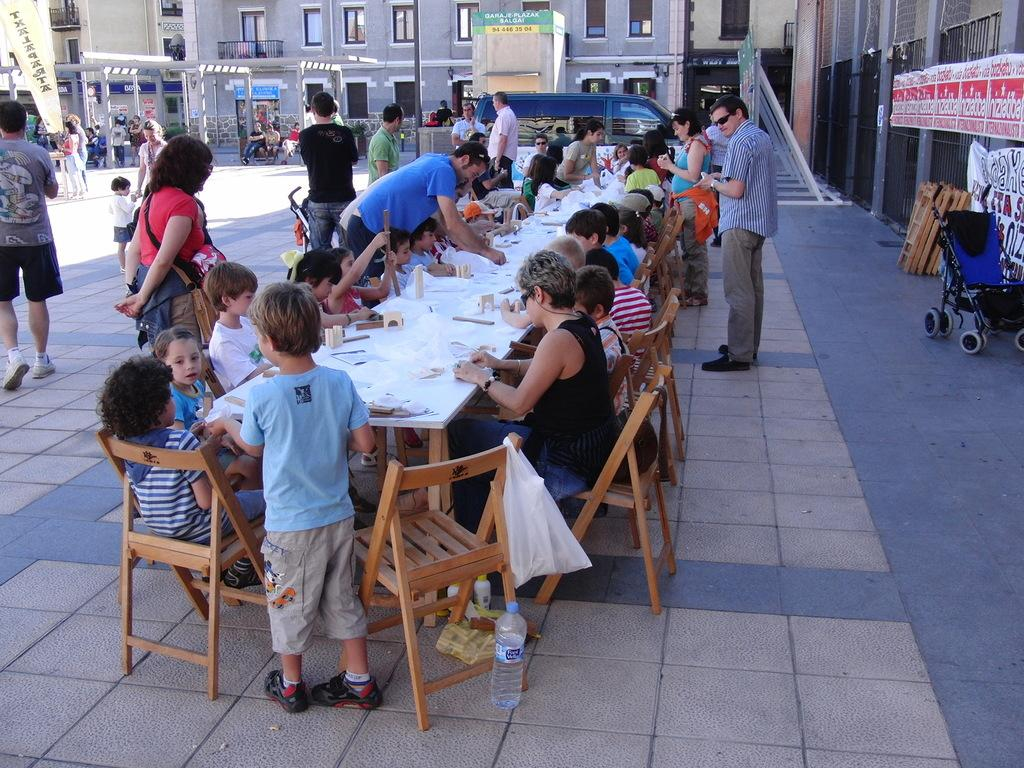What are the people in the image doing? There are people sitting on chairs and standing on the road in the image. What can be seen in the background of the image? There are buildings visible in the background of the image. Can you describe the locket that the giraffe is wearing in the image? There is no giraffe or locket present in the image. 